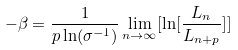Convert formula to latex. <formula><loc_0><loc_0><loc_500><loc_500>- \beta = \frac { 1 } { p \ln ( \sigma ^ { - 1 } ) } \lim _ { n \rightarrow \infty } [ \ln [ \frac { L _ { n } } { L _ { n + p } } ] ]</formula> 